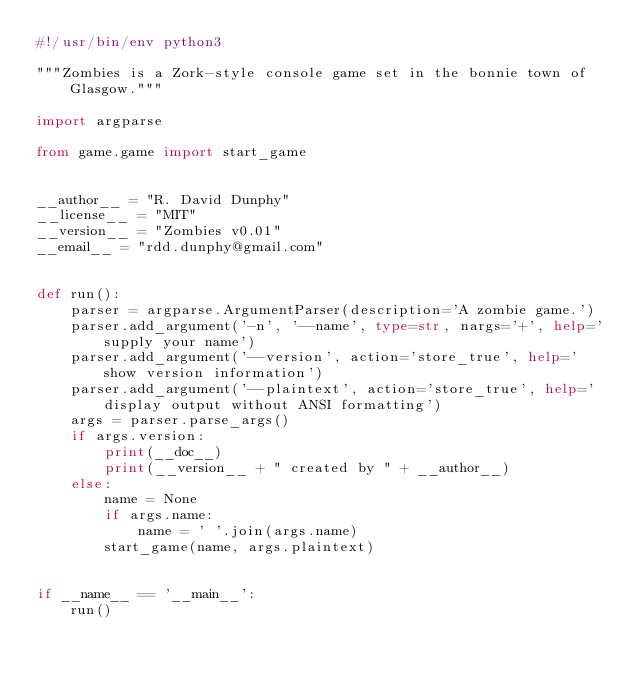Convert code to text. <code><loc_0><loc_0><loc_500><loc_500><_Python_>#!/usr/bin/env python3

"""Zombies is a Zork-style console game set in the bonnie town of Glasgow."""

import argparse

from game.game import start_game


__author__ = "R. David Dunphy"
__license__ = "MIT"
__version__ = "Zombies v0.01"
__email__ = "rdd.dunphy@gmail.com"


def run():
    parser = argparse.ArgumentParser(description='A zombie game.')
    parser.add_argument('-n', '--name', type=str, nargs='+', help='supply your name')
    parser.add_argument('--version', action='store_true', help='show version information')
    parser.add_argument('--plaintext', action='store_true', help='display output without ANSI formatting')
    args = parser.parse_args()
    if args.version:
        print(__doc__)
        print(__version__ + " created by " + __author__)
    else:
        name = None
        if args.name:
            name = ' '.join(args.name)
        start_game(name, args.plaintext)


if __name__ == '__main__':
    run()
</code> 